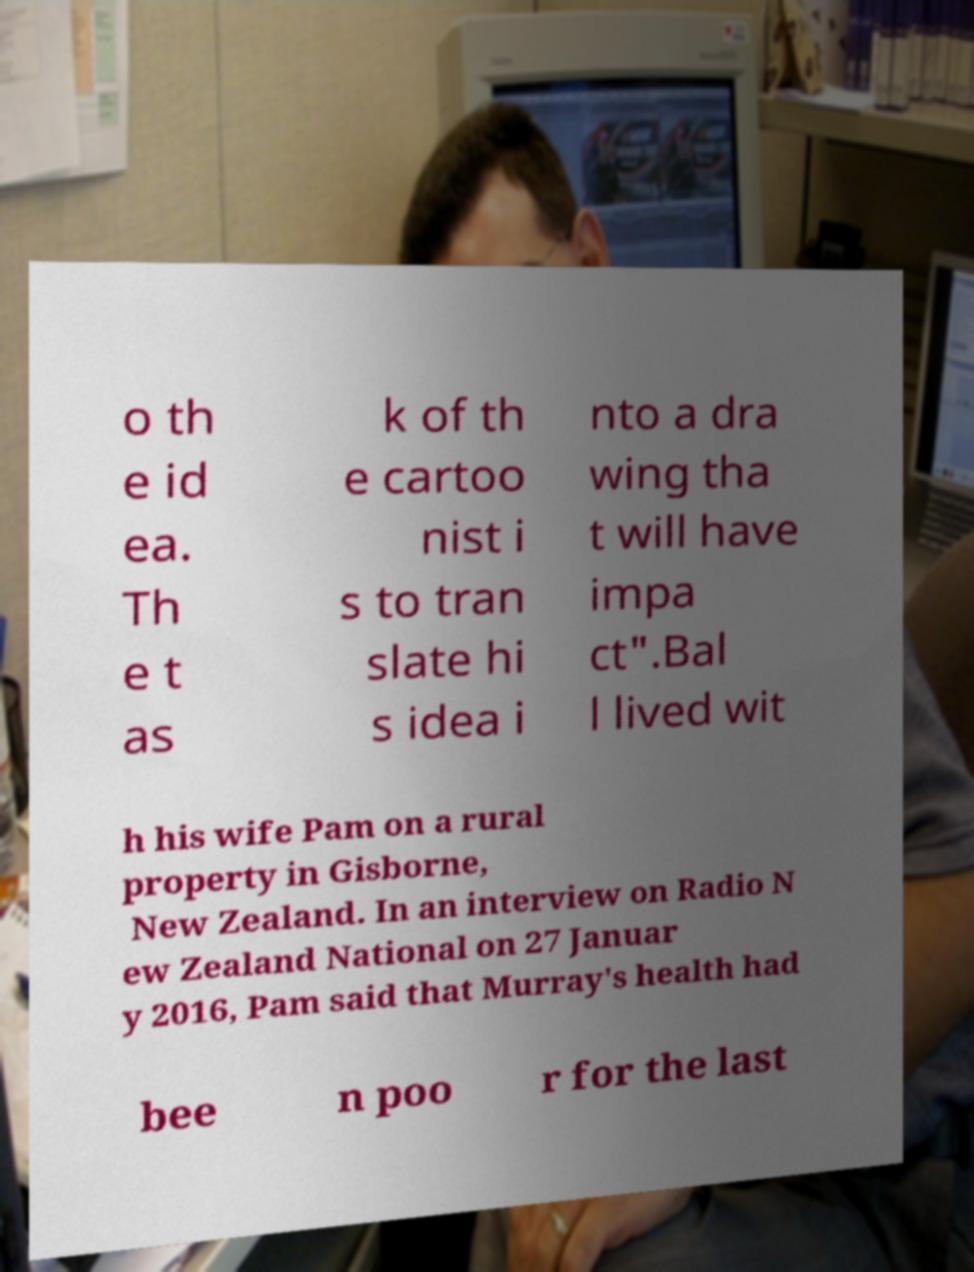Please read and relay the text visible in this image. What does it say? o th e id ea. Th e t as k of th e cartoo nist i s to tran slate hi s idea i nto a dra wing tha t will have impa ct".Bal l lived wit h his wife Pam on a rural property in Gisborne, New Zealand. In an interview on Radio N ew Zealand National on 27 Januar y 2016, Pam said that Murray's health had bee n poo r for the last 